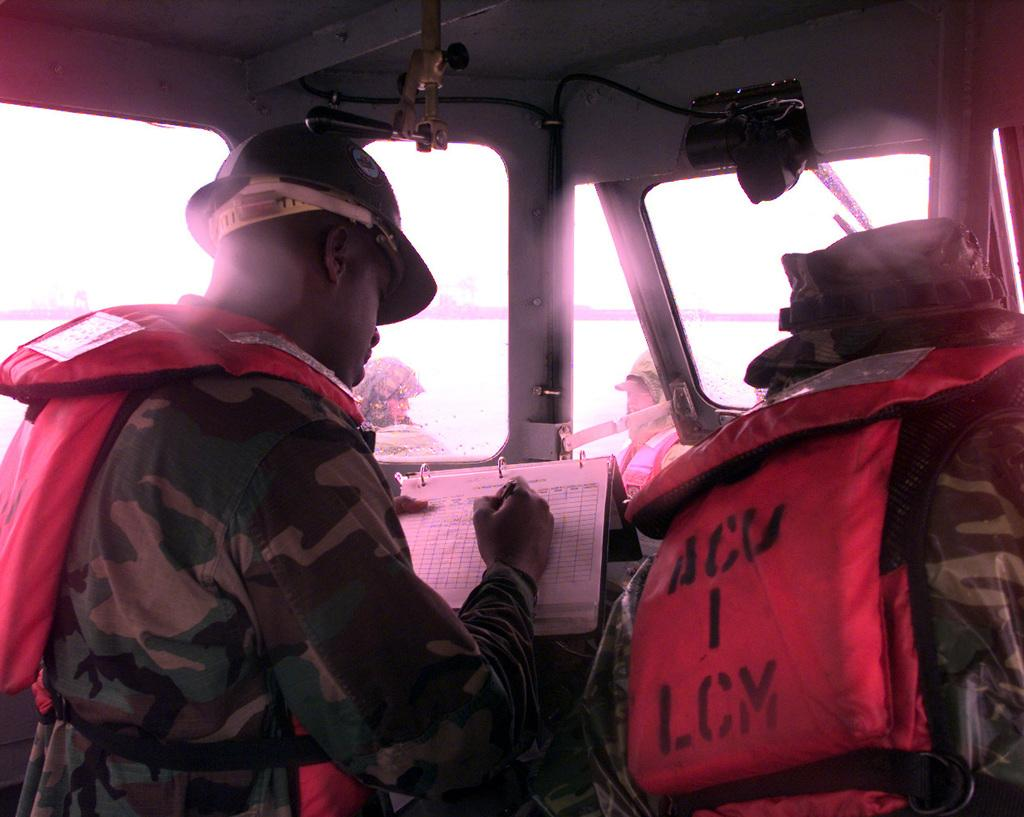How many people are inside the vehicle in the image? There are two persons sitting in the vehicle. What is one of the persons doing while sitting in the vehicle? One of the persons is writing in a book. How many people are outside the vehicle in the image? There are two other persons standing outside the vehicle. What feature of the vehicle allows for visibility from the inside? The vehicle has glass windows. Is there steam coming out of the vehicle's exhaust in the image? There is no information about the vehicle's exhaust or steam in the image, so it cannot be determined. 